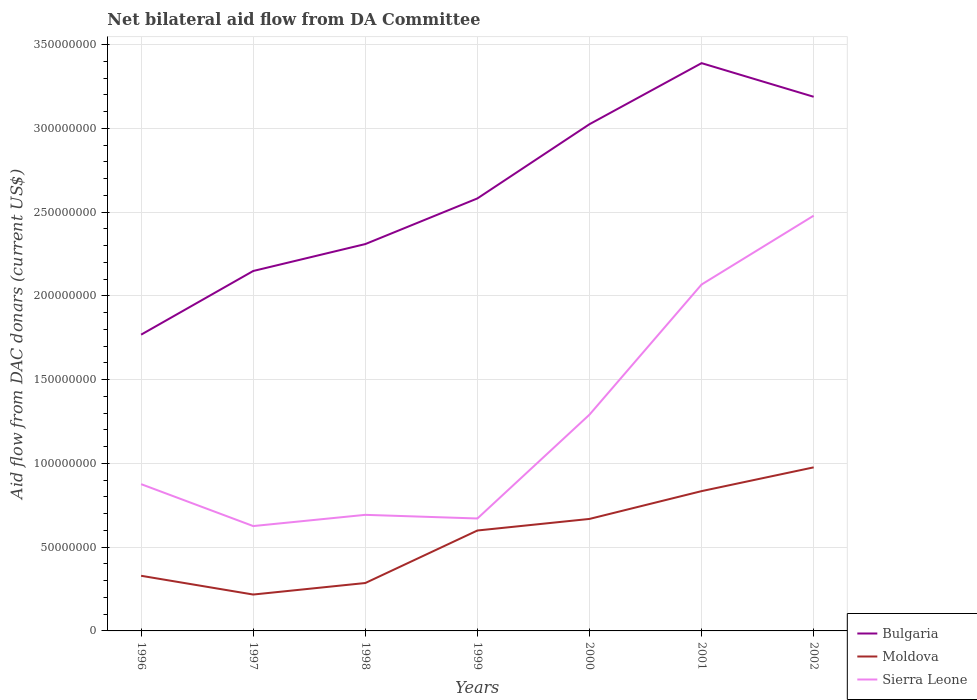How many different coloured lines are there?
Your answer should be very brief. 3. Is the number of lines equal to the number of legend labels?
Ensure brevity in your answer.  Yes. Across all years, what is the maximum aid flow in in Moldova?
Offer a terse response. 2.17e+07. In which year was the aid flow in in Bulgaria maximum?
Give a very brief answer. 1996. What is the total aid flow in in Moldova in the graph?
Provide a succinct answer. -2.70e+07. What is the difference between the highest and the second highest aid flow in in Bulgaria?
Ensure brevity in your answer.  1.62e+08. What is the difference between the highest and the lowest aid flow in in Sierra Leone?
Offer a terse response. 3. How many years are there in the graph?
Your response must be concise. 7. Does the graph contain any zero values?
Provide a short and direct response. No. Does the graph contain grids?
Provide a succinct answer. Yes. Where does the legend appear in the graph?
Make the answer very short. Bottom right. How are the legend labels stacked?
Give a very brief answer. Vertical. What is the title of the graph?
Provide a short and direct response. Net bilateral aid flow from DA Committee. What is the label or title of the X-axis?
Give a very brief answer. Years. What is the label or title of the Y-axis?
Your answer should be compact. Aid flow from DAC donars (current US$). What is the Aid flow from DAC donars (current US$) in Bulgaria in 1996?
Your response must be concise. 1.77e+08. What is the Aid flow from DAC donars (current US$) of Moldova in 1996?
Offer a terse response. 3.29e+07. What is the Aid flow from DAC donars (current US$) in Sierra Leone in 1996?
Ensure brevity in your answer.  8.76e+07. What is the Aid flow from DAC donars (current US$) of Bulgaria in 1997?
Offer a terse response. 2.15e+08. What is the Aid flow from DAC donars (current US$) in Moldova in 1997?
Offer a terse response. 2.17e+07. What is the Aid flow from DAC donars (current US$) of Sierra Leone in 1997?
Offer a very short reply. 6.26e+07. What is the Aid flow from DAC donars (current US$) of Bulgaria in 1998?
Offer a terse response. 2.31e+08. What is the Aid flow from DAC donars (current US$) in Moldova in 1998?
Ensure brevity in your answer.  2.86e+07. What is the Aid flow from DAC donars (current US$) of Sierra Leone in 1998?
Give a very brief answer. 6.93e+07. What is the Aid flow from DAC donars (current US$) in Bulgaria in 1999?
Offer a terse response. 2.58e+08. What is the Aid flow from DAC donars (current US$) of Moldova in 1999?
Keep it short and to the point. 6.00e+07. What is the Aid flow from DAC donars (current US$) of Sierra Leone in 1999?
Your answer should be compact. 6.71e+07. What is the Aid flow from DAC donars (current US$) in Bulgaria in 2000?
Make the answer very short. 3.03e+08. What is the Aid flow from DAC donars (current US$) of Moldova in 2000?
Provide a short and direct response. 6.69e+07. What is the Aid flow from DAC donars (current US$) in Sierra Leone in 2000?
Give a very brief answer. 1.29e+08. What is the Aid flow from DAC donars (current US$) in Bulgaria in 2001?
Give a very brief answer. 3.39e+08. What is the Aid flow from DAC donars (current US$) in Moldova in 2001?
Make the answer very short. 8.35e+07. What is the Aid flow from DAC donars (current US$) of Sierra Leone in 2001?
Provide a succinct answer. 2.07e+08. What is the Aid flow from DAC donars (current US$) of Bulgaria in 2002?
Your answer should be compact. 3.19e+08. What is the Aid flow from DAC donars (current US$) of Moldova in 2002?
Ensure brevity in your answer.  9.76e+07. What is the Aid flow from DAC donars (current US$) of Sierra Leone in 2002?
Your answer should be compact. 2.48e+08. Across all years, what is the maximum Aid flow from DAC donars (current US$) of Bulgaria?
Make the answer very short. 3.39e+08. Across all years, what is the maximum Aid flow from DAC donars (current US$) in Moldova?
Provide a short and direct response. 9.76e+07. Across all years, what is the maximum Aid flow from DAC donars (current US$) in Sierra Leone?
Offer a very short reply. 2.48e+08. Across all years, what is the minimum Aid flow from DAC donars (current US$) of Bulgaria?
Give a very brief answer. 1.77e+08. Across all years, what is the minimum Aid flow from DAC donars (current US$) in Moldova?
Keep it short and to the point. 2.17e+07. Across all years, what is the minimum Aid flow from DAC donars (current US$) in Sierra Leone?
Your response must be concise. 6.26e+07. What is the total Aid flow from DAC donars (current US$) in Bulgaria in the graph?
Provide a succinct answer. 1.84e+09. What is the total Aid flow from DAC donars (current US$) of Moldova in the graph?
Make the answer very short. 3.91e+08. What is the total Aid flow from DAC donars (current US$) in Sierra Leone in the graph?
Provide a short and direct response. 8.70e+08. What is the difference between the Aid flow from DAC donars (current US$) in Bulgaria in 1996 and that in 1997?
Give a very brief answer. -3.80e+07. What is the difference between the Aid flow from DAC donars (current US$) in Moldova in 1996 and that in 1997?
Ensure brevity in your answer.  1.12e+07. What is the difference between the Aid flow from DAC donars (current US$) in Sierra Leone in 1996 and that in 1997?
Offer a terse response. 2.50e+07. What is the difference between the Aid flow from DAC donars (current US$) in Bulgaria in 1996 and that in 1998?
Provide a succinct answer. -5.41e+07. What is the difference between the Aid flow from DAC donars (current US$) in Moldova in 1996 and that in 1998?
Offer a very short reply. 4.32e+06. What is the difference between the Aid flow from DAC donars (current US$) of Sierra Leone in 1996 and that in 1998?
Keep it short and to the point. 1.83e+07. What is the difference between the Aid flow from DAC donars (current US$) in Bulgaria in 1996 and that in 1999?
Make the answer very short. -8.13e+07. What is the difference between the Aid flow from DAC donars (current US$) of Moldova in 1996 and that in 1999?
Ensure brevity in your answer.  -2.70e+07. What is the difference between the Aid flow from DAC donars (current US$) in Sierra Leone in 1996 and that in 1999?
Your response must be concise. 2.05e+07. What is the difference between the Aid flow from DAC donars (current US$) of Bulgaria in 1996 and that in 2000?
Keep it short and to the point. -1.26e+08. What is the difference between the Aid flow from DAC donars (current US$) in Moldova in 1996 and that in 2000?
Provide a short and direct response. -3.39e+07. What is the difference between the Aid flow from DAC donars (current US$) of Sierra Leone in 1996 and that in 2000?
Your response must be concise. -4.15e+07. What is the difference between the Aid flow from DAC donars (current US$) in Bulgaria in 1996 and that in 2001?
Make the answer very short. -1.62e+08. What is the difference between the Aid flow from DAC donars (current US$) of Moldova in 1996 and that in 2001?
Give a very brief answer. -5.05e+07. What is the difference between the Aid flow from DAC donars (current US$) in Sierra Leone in 1996 and that in 2001?
Provide a succinct answer. -1.19e+08. What is the difference between the Aid flow from DAC donars (current US$) in Bulgaria in 1996 and that in 2002?
Offer a terse response. -1.42e+08. What is the difference between the Aid flow from DAC donars (current US$) in Moldova in 1996 and that in 2002?
Provide a short and direct response. -6.47e+07. What is the difference between the Aid flow from DAC donars (current US$) of Sierra Leone in 1996 and that in 2002?
Offer a terse response. -1.60e+08. What is the difference between the Aid flow from DAC donars (current US$) in Bulgaria in 1997 and that in 1998?
Make the answer very short. -1.61e+07. What is the difference between the Aid flow from DAC donars (current US$) of Moldova in 1997 and that in 1998?
Provide a succinct answer. -6.88e+06. What is the difference between the Aid flow from DAC donars (current US$) of Sierra Leone in 1997 and that in 1998?
Keep it short and to the point. -6.70e+06. What is the difference between the Aid flow from DAC donars (current US$) in Bulgaria in 1997 and that in 1999?
Your answer should be very brief. -4.33e+07. What is the difference between the Aid flow from DAC donars (current US$) of Moldova in 1997 and that in 1999?
Provide a short and direct response. -3.82e+07. What is the difference between the Aid flow from DAC donars (current US$) of Sierra Leone in 1997 and that in 1999?
Make the answer very short. -4.52e+06. What is the difference between the Aid flow from DAC donars (current US$) of Bulgaria in 1997 and that in 2000?
Your answer should be compact. -8.76e+07. What is the difference between the Aid flow from DAC donars (current US$) of Moldova in 1997 and that in 2000?
Your answer should be very brief. -4.51e+07. What is the difference between the Aid flow from DAC donars (current US$) in Sierra Leone in 1997 and that in 2000?
Your response must be concise. -6.65e+07. What is the difference between the Aid flow from DAC donars (current US$) in Bulgaria in 1997 and that in 2001?
Give a very brief answer. -1.24e+08. What is the difference between the Aid flow from DAC donars (current US$) in Moldova in 1997 and that in 2001?
Your answer should be compact. -6.17e+07. What is the difference between the Aid flow from DAC donars (current US$) of Sierra Leone in 1997 and that in 2001?
Ensure brevity in your answer.  -1.44e+08. What is the difference between the Aid flow from DAC donars (current US$) in Bulgaria in 1997 and that in 2002?
Provide a succinct answer. -1.04e+08. What is the difference between the Aid flow from DAC donars (current US$) of Moldova in 1997 and that in 2002?
Give a very brief answer. -7.59e+07. What is the difference between the Aid flow from DAC donars (current US$) of Sierra Leone in 1997 and that in 2002?
Ensure brevity in your answer.  -1.85e+08. What is the difference between the Aid flow from DAC donars (current US$) of Bulgaria in 1998 and that in 1999?
Your response must be concise. -2.72e+07. What is the difference between the Aid flow from DAC donars (current US$) of Moldova in 1998 and that in 1999?
Your response must be concise. -3.14e+07. What is the difference between the Aid flow from DAC donars (current US$) of Sierra Leone in 1998 and that in 1999?
Ensure brevity in your answer.  2.18e+06. What is the difference between the Aid flow from DAC donars (current US$) of Bulgaria in 1998 and that in 2000?
Offer a very short reply. -7.16e+07. What is the difference between the Aid flow from DAC donars (current US$) in Moldova in 1998 and that in 2000?
Offer a very short reply. -3.83e+07. What is the difference between the Aid flow from DAC donars (current US$) in Sierra Leone in 1998 and that in 2000?
Your answer should be compact. -5.98e+07. What is the difference between the Aid flow from DAC donars (current US$) in Bulgaria in 1998 and that in 2001?
Ensure brevity in your answer.  -1.08e+08. What is the difference between the Aid flow from DAC donars (current US$) of Moldova in 1998 and that in 2001?
Give a very brief answer. -5.49e+07. What is the difference between the Aid flow from DAC donars (current US$) in Sierra Leone in 1998 and that in 2001?
Your answer should be very brief. -1.38e+08. What is the difference between the Aid flow from DAC donars (current US$) in Bulgaria in 1998 and that in 2002?
Your answer should be compact. -8.79e+07. What is the difference between the Aid flow from DAC donars (current US$) of Moldova in 1998 and that in 2002?
Offer a very short reply. -6.90e+07. What is the difference between the Aid flow from DAC donars (current US$) in Sierra Leone in 1998 and that in 2002?
Provide a short and direct response. -1.79e+08. What is the difference between the Aid flow from DAC donars (current US$) of Bulgaria in 1999 and that in 2000?
Give a very brief answer. -4.43e+07. What is the difference between the Aid flow from DAC donars (current US$) in Moldova in 1999 and that in 2000?
Your answer should be very brief. -6.91e+06. What is the difference between the Aid flow from DAC donars (current US$) in Sierra Leone in 1999 and that in 2000?
Your answer should be very brief. -6.20e+07. What is the difference between the Aid flow from DAC donars (current US$) of Bulgaria in 1999 and that in 2001?
Ensure brevity in your answer.  -8.08e+07. What is the difference between the Aid flow from DAC donars (current US$) in Moldova in 1999 and that in 2001?
Make the answer very short. -2.35e+07. What is the difference between the Aid flow from DAC donars (current US$) of Sierra Leone in 1999 and that in 2001?
Provide a short and direct response. -1.40e+08. What is the difference between the Aid flow from DAC donars (current US$) in Bulgaria in 1999 and that in 2002?
Make the answer very short. -6.07e+07. What is the difference between the Aid flow from DAC donars (current US$) of Moldova in 1999 and that in 2002?
Offer a terse response. -3.77e+07. What is the difference between the Aid flow from DAC donars (current US$) of Sierra Leone in 1999 and that in 2002?
Give a very brief answer. -1.81e+08. What is the difference between the Aid flow from DAC donars (current US$) of Bulgaria in 2000 and that in 2001?
Make the answer very short. -3.64e+07. What is the difference between the Aid flow from DAC donars (current US$) of Moldova in 2000 and that in 2001?
Your answer should be compact. -1.66e+07. What is the difference between the Aid flow from DAC donars (current US$) in Sierra Leone in 2000 and that in 2001?
Make the answer very short. -7.77e+07. What is the difference between the Aid flow from DAC donars (current US$) in Bulgaria in 2000 and that in 2002?
Your response must be concise. -1.64e+07. What is the difference between the Aid flow from DAC donars (current US$) in Moldova in 2000 and that in 2002?
Provide a succinct answer. -3.08e+07. What is the difference between the Aid flow from DAC donars (current US$) of Sierra Leone in 2000 and that in 2002?
Ensure brevity in your answer.  -1.19e+08. What is the difference between the Aid flow from DAC donars (current US$) of Bulgaria in 2001 and that in 2002?
Offer a terse response. 2.01e+07. What is the difference between the Aid flow from DAC donars (current US$) in Moldova in 2001 and that in 2002?
Keep it short and to the point. -1.42e+07. What is the difference between the Aid flow from DAC donars (current US$) in Sierra Leone in 2001 and that in 2002?
Provide a short and direct response. -4.11e+07. What is the difference between the Aid flow from DAC donars (current US$) in Bulgaria in 1996 and the Aid flow from DAC donars (current US$) in Moldova in 1997?
Make the answer very short. 1.55e+08. What is the difference between the Aid flow from DAC donars (current US$) in Bulgaria in 1996 and the Aid flow from DAC donars (current US$) in Sierra Leone in 1997?
Make the answer very short. 1.14e+08. What is the difference between the Aid flow from DAC donars (current US$) in Moldova in 1996 and the Aid flow from DAC donars (current US$) in Sierra Leone in 1997?
Offer a terse response. -2.97e+07. What is the difference between the Aid flow from DAC donars (current US$) in Bulgaria in 1996 and the Aid flow from DAC donars (current US$) in Moldova in 1998?
Offer a terse response. 1.48e+08. What is the difference between the Aid flow from DAC donars (current US$) in Bulgaria in 1996 and the Aid flow from DAC donars (current US$) in Sierra Leone in 1998?
Your answer should be very brief. 1.08e+08. What is the difference between the Aid flow from DAC donars (current US$) of Moldova in 1996 and the Aid flow from DAC donars (current US$) of Sierra Leone in 1998?
Ensure brevity in your answer.  -3.64e+07. What is the difference between the Aid flow from DAC donars (current US$) in Bulgaria in 1996 and the Aid flow from DAC donars (current US$) in Moldova in 1999?
Your answer should be compact. 1.17e+08. What is the difference between the Aid flow from DAC donars (current US$) of Bulgaria in 1996 and the Aid flow from DAC donars (current US$) of Sierra Leone in 1999?
Provide a short and direct response. 1.10e+08. What is the difference between the Aid flow from DAC donars (current US$) of Moldova in 1996 and the Aid flow from DAC donars (current US$) of Sierra Leone in 1999?
Give a very brief answer. -3.42e+07. What is the difference between the Aid flow from DAC donars (current US$) of Bulgaria in 1996 and the Aid flow from DAC donars (current US$) of Moldova in 2000?
Provide a succinct answer. 1.10e+08. What is the difference between the Aid flow from DAC donars (current US$) in Bulgaria in 1996 and the Aid flow from DAC donars (current US$) in Sierra Leone in 2000?
Offer a very short reply. 4.78e+07. What is the difference between the Aid flow from DAC donars (current US$) in Moldova in 1996 and the Aid flow from DAC donars (current US$) in Sierra Leone in 2000?
Give a very brief answer. -9.62e+07. What is the difference between the Aid flow from DAC donars (current US$) of Bulgaria in 1996 and the Aid flow from DAC donars (current US$) of Moldova in 2001?
Your response must be concise. 9.34e+07. What is the difference between the Aid flow from DAC donars (current US$) in Bulgaria in 1996 and the Aid flow from DAC donars (current US$) in Sierra Leone in 2001?
Give a very brief answer. -2.99e+07. What is the difference between the Aid flow from DAC donars (current US$) in Moldova in 1996 and the Aid flow from DAC donars (current US$) in Sierra Leone in 2001?
Make the answer very short. -1.74e+08. What is the difference between the Aid flow from DAC donars (current US$) in Bulgaria in 1996 and the Aid flow from DAC donars (current US$) in Moldova in 2002?
Keep it short and to the point. 7.92e+07. What is the difference between the Aid flow from DAC donars (current US$) in Bulgaria in 1996 and the Aid flow from DAC donars (current US$) in Sierra Leone in 2002?
Provide a succinct answer. -7.10e+07. What is the difference between the Aid flow from DAC donars (current US$) in Moldova in 1996 and the Aid flow from DAC donars (current US$) in Sierra Leone in 2002?
Give a very brief answer. -2.15e+08. What is the difference between the Aid flow from DAC donars (current US$) in Bulgaria in 1997 and the Aid flow from DAC donars (current US$) in Moldova in 1998?
Keep it short and to the point. 1.86e+08. What is the difference between the Aid flow from DAC donars (current US$) in Bulgaria in 1997 and the Aid flow from DAC donars (current US$) in Sierra Leone in 1998?
Provide a short and direct response. 1.46e+08. What is the difference between the Aid flow from DAC donars (current US$) of Moldova in 1997 and the Aid flow from DAC donars (current US$) of Sierra Leone in 1998?
Your answer should be very brief. -4.76e+07. What is the difference between the Aid flow from DAC donars (current US$) of Bulgaria in 1997 and the Aid flow from DAC donars (current US$) of Moldova in 1999?
Ensure brevity in your answer.  1.55e+08. What is the difference between the Aid flow from DAC donars (current US$) in Bulgaria in 1997 and the Aid flow from DAC donars (current US$) in Sierra Leone in 1999?
Provide a succinct answer. 1.48e+08. What is the difference between the Aid flow from DAC donars (current US$) of Moldova in 1997 and the Aid flow from DAC donars (current US$) of Sierra Leone in 1999?
Offer a terse response. -4.54e+07. What is the difference between the Aid flow from DAC donars (current US$) of Bulgaria in 1997 and the Aid flow from DAC donars (current US$) of Moldova in 2000?
Keep it short and to the point. 1.48e+08. What is the difference between the Aid flow from DAC donars (current US$) in Bulgaria in 1997 and the Aid flow from DAC donars (current US$) in Sierra Leone in 2000?
Ensure brevity in your answer.  8.58e+07. What is the difference between the Aid flow from DAC donars (current US$) in Moldova in 1997 and the Aid flow from DAC donars (current US$) in Sierra Leone in 2000?
Make the answer very short. -1.07e+08. What is the difference between the Aid flow from DAC donars (current US$) of Bulgaria in 1997 and the Aid flow from DAC donars (current US$) of Moldova in 2001?
Your answer should be very brief. 1.31e+08. What is the difference between the Aid flow from DAC donars (current US$) in Bulgaria in 1997 and the Aid flow from DAC donars (current US$) in Sierra Leone in 2001?
Make the answer very short. 8.07e+06. What is the difference between the Aid flow from DAC donars (current US$) of Moldova in 1997 and the Aid flow from DAC donars (current US$) of Sierra Leone in 2001?
Your answer should be compact. -1.85e+08. What is the difference between the Aid flow from DAC donars (current US$) in Bulgaria in 1997 and the Aid flow from DAC donars (current US$) in Moldova in 2002?
Your answer should be compact. 1.17e+08. What is the difference between the Aid flow from DAC donars (current US$) of Bulgaria in 1997 and the Aid flow from DAC donars (current US$) of Sierra Leone in 2002?
Offer a terse response. -3.30e+07. What is the difference between the Aid flow from DAC donars (current US$) of Moldova in 1997 and the Aid flow from DAC donars (current US$) of Sierra Leone in 2002?
Offer a terse response. -2.26e+08. What is the difference between the Aid flow from DAC donars (current US$) in Bulgaria in 1998 and the Aid flow from DAC donars (current US$) in Moldova in 1999?
Provide a succinct answer. 1.71e+08. What is the difference between the Aid flow from DAC donars (current US$) of Bulgaria in 1998 and the Aid flow from DAC donars (current US$) of Sierra Leone in 1999?
Your answer should be very brief. 1.64e+08. What is the difference between the Aid flow from DAC donars (current US$) of Moldova in 1998 and the Aid flow from DAC donars (current US$) of Sierra Leone in 1999?
Your answer should be compact. -3.85e+07. What is the difference between the Aid flow from DAC donars (current US$) in Bulgaria in 1998 and the Aid flow from DAC donars (current US$) in Moldova in 2000?
Your answer should be very brief. 1.64e+08. What is the difference between the Aid flow from DAC donars (current US$) of Bulgaria in 1998 and the Aid flow from DAC donars (current US$) of Sierra Leone in 2000?
Ensure brevity in your answer.  1.02e+08. What is the difference between the Aid flow from DAC donars (current US$) of Moldova in 1998 and the Aid flow from DAC donars (current US$) of Sierra Leone in 2000?
Provide a short and direct response. -1.01e+08. What is the difference between the Aid flow from DAC donars (current US$) of Bulgaria in 1998 and the Aid flow from DAC donars (current US$) of Moldova in 2001?
Provide a succinct answer. 1.47e+08. What is the difference between the Aid flow from DAC donars (current US$) in Bulgaria in 1998 and the Aid flow from DAC donars (current US$) in Sierra Leone in 2001?
Your response must be concise. 2.41e+07. What is the difference between the Aid flow from DAC donars (current US$) of Moldova in 1998 and the Aid flow from DAC donars (current US$) of Sierra Leone in 2001?
Offer a very short reply. -1.78e+08. What is the difference between the Aid flow from DAC donars (current US$) in Bulgaria in 1998 and the Aid flow from DAC donars (current US$) in Moldova in 2002?
Your answer should be very brief. 1.33e+08. What is the difference between the Aid flow from DAC donars (current US$) in Bulgaria in 1998 and the Aid flow from DAC donars (current US$) in Sierra Leone in 2002?
Make the answer very short. -1.70e+07. What is the difference between the Aid flow from DAC donars (current US$) of Moldova in 1998 and the Aid flow from DAC donars (current US$) of Sierra Leone in 2002?
Provide a short and direct response. -2.19e+08. What is the difference between the Aid flow from DAC donars (current US$) in Bulgaria in 1999 and the Aid flow from DAC donars (current US$) in Moldova in 2000?
Keep it short and to the point. 1.91e+08. What is the difference between the Aid flow from DAC donars (current US$) in Bulgaria in 1999 and the Aid flow from DAC donars (current US$) in Sierra Leone in 2000?
Give a very brief answer. 1.29e+08. What is the difference between the Aid flow from DAC donars (current US$) of Moldova in 1999 and the Aid flow from DAC donars (current US$) of Sierra Leone in 2000?
Your answer should be compact. -6.92e+07. What is the difference between the Aid flow from DAC donars (current US$) in Bulgaria in 1999 and the Aid flow from DAC donars (current US$) in Moldova in 2001?
Your answer should be compact. 1.75e+08. What is the difference between the Aid flow from DAC donars (current US$) in Bulgaria in 1999 and the Aid flow from DAC donars (current US$) in Sierra Leone in 2001?
Your response must be concise. 5.14e+07. What is the difference between the Aid flow from DAC donars (current US$) in Moldova in 1999 and the Aid flow from DAC donars (current US$) in Sierra Leone in 2001?
Provide a succinct answer. -1.47e+08. What is the difference between the Aid flow from DAC donars (current US$) in Bulgaria in 1999 and the Aid flow from DAC donars (current US$) in Moldova in 2002?
Offer a very short reply. 1.61e+08. What is the difference between the Aid flow from DAC donars (current US$) of Bulgaria in 1999 and the Aid flow from DAC donars (current US$) of Sierra Leone in 2002?
Provide a succinct answer. 1.03e+07. What is the difference between the Aid flow from DAC donars (current US$) of Moldova in 1999 and the Aid flow from DAC donars (current US$) of Sierra Leone in 2002?
Provide a short and direct response. -1.88e+08. What is the difference between the Aid flow from DAC donars (current US$) in Bulgaria in 2000 and the Aid flow from DAC donars (current US$) in Moldova in 2001?
Your response must be concise. 2.19e+08. What is the difference between the Aid flow from DAC donars (current US$) in Bulgaria in 2000 and the Aid flow from DAC donars (current US$) in Sierra Leone in 2001?
Provide a short and direct response. 9.57e+07. What is the difference between the Aid flow from DAC donars (current US$) of Moldova in 2000 and the Aid flow from DAC donars (current US$) of Sierra Leone in 2001?
Provide a short and direct response. -1.40e+08. What is the difference between the Aid flow from DAC donars (current US$) in Bulgaria in 2000 and the Aid flow from DAC donars (current US$) in Moldova in 2002?
Make the answer very short. 2.05e+08. What is the difference between the Aid flow from DAC donars (current US$) of Bulgaria in 2000 and the Aid flow from DAC donars (current US$) of Sierra Leone in 2002?
Give a very brief answer. 5.46e+07. What is the difference between the Aid flow from DAC donars (current US$) in Moldova in 2000 and the Aid flow from DAC donars (current US$) in Sierra Leone in 2002?
Ensure brevity in your answer.  -1.81e+08. What is the difference between the Aid flow from DAC donars (current US$) in Bulgaria in 2001 and the Aid flow from DAC donars (current US$) in Moldova in 2002?
Your answer should be compact. 2.41e+08. What is the difference between the Aid flow from DAC donars (current US$) of Bulgaria in 2001 and the Aid flow from DAC donars (current US$) of Sierra Leone in 2002?
Provide a succinct answer. 9.10e+07. What is the difference between the Aid flow from DAC donars (current US$) of Moldova in 2001 and the Aid flow from DAC donars (current US$) of Sierra Leone in 2002?
Provide a succinct answer. -1.64e+08. What is the average Aid flow from DAC donars (current US$) of Bulgaria per year?
Offer a terse response. 2.63e+08. What is the average Aid flow from DAC donars (current US$) of Moldova per year?
Give a very brief answer. 5.59e+07. What is the average Aid flow from DAC donars (current US$) in Sierra Leone per year?
Keep it short and to the point. 1.24e+08. In the year 1996, what is the difference between the Aid flow from DAC donars (current US$) in Bulgaria and Aid flow from DAC donars (current US$) in Moldova?
Make the answer very short. 1.44e+08. In the year 1996, what is the difference between the Aid flow from DAC donars (current US$) of Bulgaria and Aid flow from DAC donars (current US$) of Sierra Leone?
Your answer should be compact. 8.92e+07. In the year 1996, what is the difference between the Aid flow from DAC donars (current US$) in Moldova and Aid flow from DAC donars (current US$) in Sierra Leone?
Offer a very short reply. -5.47e+07. In the year 1997, what is the difference between the Aid flow from DAC donars (current US$) of Bulgaria and Aid flow from DAC donars (current US$) of Moldova?
Keep it short and to the point. 1.93e+08. In the year 1997, what is the difference between the Aid flow from DAC donars (current US$) in Bulgaria and Aid flow from DAC donars (current US$) in Sierra Leone?
Offer a terse response. 1.52e+08. In the year 1997, what is the difference between the Aid flow from DAC donars (current US$) in Moldova and Aid flow from DAC donars (current US$) in Sierra Leone?
Your answer should be compact. -4.09e+07. In the year 1998, what is the difference between the Aid flow from DAC donars (current US$) of Bulgaria and Aid flow from DAC donars (current US$) of Moldova?
Your answer should be very brief. 2.02e+08. In the year 1998, what is the difference between the Aid flow from DAC donars (current US$) of Bulgaria and Aid flow from DAC donars (current US$) of Sierra Leone?
Your response must be concise. 1.62e+08. In the year 1998, what is the difference between the Aid flow from DAC donars (current US$) in Moldova and Aid flow from DAC donars (current US$) in Sierra Leone?
Offer a very short reply. -4.07e+07. In the year 1999, what is the difference between the Aid flow from DAC donars (current US$) in Bulgaria and Aid flow from DAC donars (current US$) in Moldova?
Provide a short and direct response. 1.98e+08. In the year 1999, what is the difference between the Aid flow from DAC donars (current US$) in Bulgaria and Aid flow from DAC donars (current US$) in Sierra Leone?
Provide a short and direct response. 1.91e+08. In the year 1999, what is the difference between the Aid flow from DAC donars (current US$) of Moldova and Aid flow from DAC donars (current US$) of Sierra Leone?
Your response must be concise. -7.17e+06. In the year 2000, what is the difference between the Aid flow from DAC donars (current US$) in Bulgaria and Aid flow from DAC donars (current US$) in Moldova?
Provide a short and direct response. 2.36e+08. In the year 2000, what is the difference between the Aid flow from DAC donars (current US$) of Bulgaria and Aid flow from DAC donars (current US$) of Sierra Leone?
Provide a short and direct response. 1.73e+08. In the year 2000, what is the difference between the Aid flow from DAC donars (current US$) in Moldova and Aid flow from DAC donars (current US$) in Sierra Leone?
Your answer should be compact. -6.23e+07. In the year 2001, what is the difference between the Aid flow from DAC donars (current US$) in Bulgaria and Aid flow from DAC donars (current US$) in Moldova?
Keep it short and to the point. 2.56e+08. In the year 2001, what is the difference between the Aid flow from DAC donars (current US$) of Bulgaria and Aid flow from DAC donars (current US$) of Sierra Leone?
Provide a short and direct response. 1.32e+08. In the year 2001, what is the difference between the Aid flow from DAC donars (current US$) in Moldova and Aid flow from DAC donars (current US$) in Sierra Leone?
Provide a succinct answer. -1.23e+08. In the year 2002, what is the difference between the Aid flow from DAC donars (current US$) of Bulgaria and Aid flow from DAC donars (current US$) of Moldova?
Ensure brevity in your answer.  2.21e+08. In the year 2002, what is the difference between the Aid flow from DAC donars (current US$) in Bulgaria and Aid flow from DAC donars (current US$) in Sierra Leone?
Make the answer very short. 7.10e+07. In the year 2002, what is the difference between the Aid flow from DAC donars (current US$) of Moldova and Aid flow from DAC donars (current US$) of Sierra Leone?
Offer a terse response. -1.50e+08. What is the ratio of the Aid flow from DAC donars (current US$) in Bulgaria in 1996 to that in 1997?
Your response must be concise. 0.82. What is the ratio of the Aid flow from DAC donars (current US$) in Moldova in 1996 to that in 1997?
Provide a succinct answer. 1.52. What is the ratio of the Aid flow from DAC donars (current US$) of Sierra Leone in 1996 to that in 1997?
Offer a terse response. 1.4. What is the ratio of the Aid flow from DAC donars (current US$) in Bulgaria in 1996 to that in 1998?
Provide a succinct answer. 0.77. What is the ratio of the Aid flow from DAC donars (current US$) of Moldova in 1996 to that in 1998?
Provide a succinct answer. 1.15. What is the ratio of the Aid flow from DAC donars (current US$) of Sierra Leone in 1996 to that in 1998?
Offer a very short reply. 1.26. What is the ratio of the Aid flow from DAC donars (current US$) in Bulgaria in 1996 to that in 1999?
Offer a terse response. 0.69. What is the ratio of the Aid flow from DAC donars (current US$) of Moldova in 1996 to that in 1999?
Offer a terse response. 0.55. What is the ratio of the Aid flow from DAC donars (current US$) in Sierra Leone in 1996 to that in 1999?
Your answer should be compact. 1.31. What is the ratio of the Aid flow from DAC donars (current US$) of Bulgaria in 1996 to that in 2000?
Provide a short and direct response. 0.58. What is the ratio of the Aid flow from DAC donars (current US$) in Moldova in 1996 to that in 2000?
Offer a terse response. 0.49. What is the ratio of the Aid flow from DAC donars (current US$) in Sierra Leone in 1996 to that in 2000?
Your answer should be very brief. 0.68. What is the ratio of the Aid flow from DAC donars (current US$) in Bulgaria in 1996 to that in 2001?
Your answer should be very brief. 0.52. What is the ratio of the Aid flow from DAC donars (current US$) in Moldova in 1996 to that in 2001?
Give a very brief answer. 0.39. What is the ratio of the Aid flow from DAC donars (current US$) of Sierra Leone in 1996 to that in 2001?
Make the answer very short. 0.42. What is the ratio of the Aid flow from DAC donars (current US$) in Bulgaria in 1996 to that in 2002?
Provide a short and direct response. 0.55. What is the ratio of the Aid flow from DAC donars (current US$) of Moldova in 1996 to that in 2002?
Your answer should be very brief. 0.34. What is the ratio of the Aid flow from DAC donars (current US$) in Sierra Leone in 1996 to that in 2002?
Your response must be concise. 0.35. What is the ratio of the Aid flow from DAC donars (current US$) of Bulgaria in 1997 to that in 1998?
Ensure brevity in your answer.  0.93. What is the ratio of the Aid flow from DAC donars (current US$) in Moldova in 1997 to that in 1998?
Offer a terse response. 0.76. What is the ratio of the Aid flow from DAC donars (current US$) of Sierra Leone in 1997 to that in 1998?
Ensure brevity in your answer.  0.9. What is the ratio of the Aid flow from DAC donars (current US$) in Bulgaria in 1997 to that in 1999?
Offer a very short reply. 0.83. What is the ratio of the Aid flow from DAC donars (current US$) of Moldova in 1997 to that in 1999?
Ensure brevity in your answer.  0.36. What is the ratio of the Aid flow from DAC donars (current US$) in Sierra Leone in 1997 to that in 1999?
Keep it short and to the point. 0.93. What is the ratio of the Aid flow from DAC donars (current US$) of Bulgaria in 1997 to that in 2000?
Your response must be concise. 0.71. What is the ratio of the Aid flow from DAC donars (current US$) in Moldova in 1997 to that in 2000?
Your answer should be very brief. 0.32. What is the ratio of the Aid flow from DAC donars (current US$) of Sierra Leone in 1997 to that in 2000?
Provide a short and direct response. 0.48. What is the ratio of the Aid flow from DAC donars (current US$) of Bulgaria in 1997 to that in 2001?
Keep it short and to the point. 0.63. What is the ratio of the Aid flow from DAC donars (current US$) in Moldova in 1997 to that in 2001?
Offer a terse response. 0.26. What is the ratio of the Aid flow from DAC donars (current US$) in Sierra Leone in 1997 to that in 2001?
Your answer should be very brief. 0.3. What is the ratio of the Aid flow from DAC donars (current US$) of Bulgaria in 1997 to that in 2002?
Offer a very short reply. 0.67. What is the ratio of the Aid flow from DAC donars (current US$) of Moldova in 1997 to that in 2002?
Your response must be concise. 0.22. What is the ratio of the Aid flow from DAC donars (current US$) in Sierra Leone in 1997 to that in 2002?
Your answer should be compact. 0.25. What is the ratio of the Aid flow from DAC donars (current US$) in Bulgaria in 1998 to that in 1999?
Your response must be concise. 0.89. What is the ratio of the Aid flow from DAC donars (current US$) in Moldova in 1998 to that in 1999?
Make the answer very short. 0.48. What is the ratio of the Aid flow from DAC donars (current US$) of Sierra Leone in 1998 to that in 1999?
Make the answer very short. 1.03. What is the ratio of the Aid flow from DAC donars (current US$) in Bulgaria in 1998 to that in 2000?
Offer a terse response. 0.76. What is the ratio of the Aid flow from DAC donars (current US$) in Moldova in 1998 to that in 2000?
Offer a very short reply. 0.43. What is the ratio of the Aid flow from DAC donars (current US$) of Sierra Leone in 1998 to that in 2000?
Give a very brief answer. 0.54. What is the ratio of the Aid flow from DAC donars (current US$) in Bulgaria in 1998 to that in 2001?
Keep it short and to the point. 0.68. What is the ratio of the Aid flow from DAC donars (current US$) in Moldova in 1998 to that in 2001?
Offer a very short reply. 0.34. What is the ratio of the Aid flow from DAC donars (current US$) in Sierra Leone in 1998 to that in 2001?
Your answer should be compact. 0.34. What is the ratio of the Aid flow from DAC donars (current US$) in Bulgaria in 1998 to that in 2002?
Keep it short and to the point. 0.72. What is the ratio of the Aid flow from DAC donars (current US$) of Moldova in 1998 to that in 2002?
Keep it short and to the point. 0.29. What is the ratio of the Aid flow from DAC donars (current US$) of Sierra Leone in 1998 to that in 2002?
Your answer should be very brief. 0.28. What is the ratio of the Aid flow from DAC donars (current US$) in Bulgaria in 1999 to that in 2000?
Provide a succinct answer. 0.85. What is the ratio of the Aid flow from DAC donars (current US$) of Moldova in 1999 to that in 2000?
Ensure brevity in your answer.  0.9. What is the ratio of the Aid flow from DAC donars (current US$) of Sierra Leone in 1999 to that in 2000?
Ensure brevity in your answer.  0.52. What is the ratio of the Aid flow from DAC donars (current US$) in Bulgaria in 1999 to that in 2001?
Provide a short and direct response. 0.76. What is the ratio of the Aid flow from DAC donars (current US$) in Moldova in 1999 to that in 2001?
Make the answer very short. 0.72. What is the ratio of the Aid flow from DAC donars (current US$) of Sierra Leone in 1999 to that in 2001?
Give a very brief answer. 0.32. What is the ratio of the Aid flow from DAC donars (current US$) of Bulgaria in 1999 to that in 2002?
Make the answer very short. 0.81. What is the ratio of the Aid flow from DAC donars (current US$) of Moldova in 1999 to that in 2002?
Give a very brief answer. 0.61. What is the ratio of the Aid flow from DAC donars (current US$) of Sierra Leone in 1999 to that in 2002?
Give a very brief answer. 0.27. What is the ratio of the Aid flow from DAC donars (current US$) in Bulgaria in 2000 to that in 2001?
Your response must be concise. 0.89. What is the ratio of the Aid flow from DAC donars (current US$) in Moldova in 2000 to that in 2001?
Provide a short and direct response. 0.8. What is the ratio of the Aid flow from DAC donars (current US$) in Sierra Leone in 2000 to that in 2001?
Offer a very short reply. 0.62. What is the ratio of the Aid flow from DAC donars (current US$) in Bulgaria in 2000 to that in 2002?
Provide a short and direct response. 0.95. What is the ratio of the Aid flow from DAC donars (current US$) in Moldova in 2000 to that in 2002?
Provide a succinct answer. 0.68. What is the ratio of the Aid flow from DAC donars (current US$) in Sierra Leone in 2000 to that in 2002?
Your answer should be very brief. 0.52. What is the ratio of the Aid flow from DAC donars (current US$) of Bulgaria in 2001 to that in 2002?
Your answer should be very brief. 1.06. What is the ratio of the Aid flow from DAC donars (current US$) in Moldova in 2001 to that in 2002?
Your answer should be very brief. 0.85. What is the ratio of the Aid flow from DAC donars (current US$) of Sierra Leone in 2001 to that in 2002?
Offer a terse response. 0.83. What is the difference between the highest and the second highest Aid flow from DAC donars (current US$) of Bulgaria?
Make the answer very short. 2.01e+07. What is the difference between the highest and the second highest Aid flow from DAC donars (current US$) of Moldova?
Your answer should be compact. 1.42e+07. What is the difference between the highest and the second highest Aid flow from DAC donars (current US$) of Sierra Leone?
Keep it short and to the point. 4.11e+07. What is the difference between the highest and the lowest Aid flow from DAC donars (current US$) of Bulgaria?
Offer a very short reply. 1.62e+08. What is the difference between the highest and the lowest Aid flow from DAC donars (current US$) in Moldova?
Give a very brief answer. 7.59e+07. What is the difference between the highest and the lowest Aid flow from DAC donars (current US$) in Sierra Leone?
Your answer should be compact. 1.85e+08. 